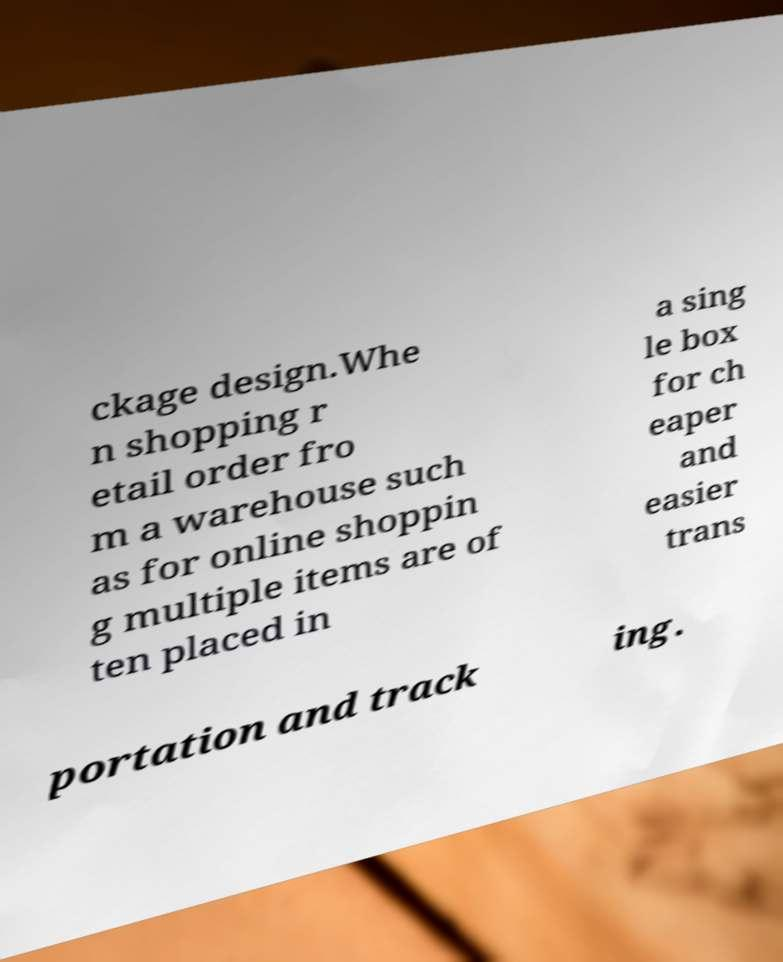I need the written content from this picture converted into text. Can you do that? ckage design.Whe n shopping r etail order fro m a warehouse such as for online shoppin g multiple items are of ten placed in a sing le box for ch eaper and easier trans portation and track ing. 